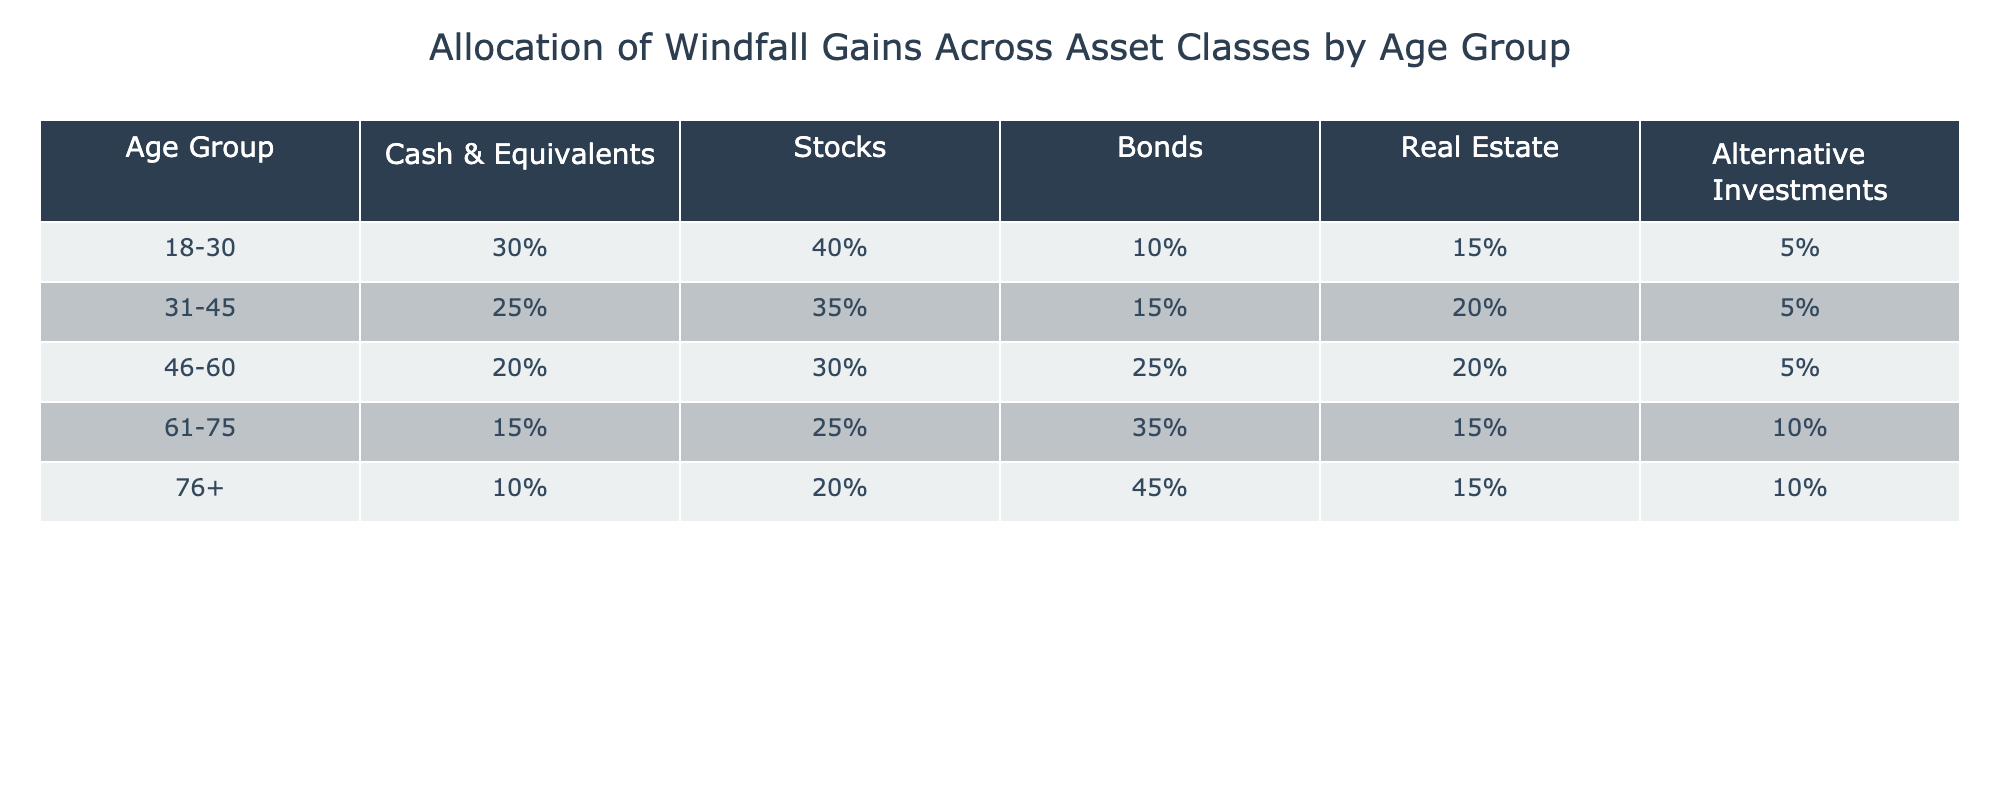What percentage of windfall gains for the 46-60 age group is allocated to stocks? The table shows a 30% allocation to stocks for the 46-60 age group.
Answer: 30% Which asset class gets the highest allocation for those aged 61-75? In the 61-75 age group, the highest allocation is 35% to bonds.
Answer: Bonds What is the difference in the allocation of cash and equivalents between the 18-30 and 76+ age groups? For the 18-30 age group the allocation is 30%, and for 76+ the allocation is 10%. The difference is 30% - 10% = 20%.
Answer: 20% Is the allocation to real estate higher for the 31-45 age group compared to the 76+ age group? The allocation for the 31-45 age group is 20%, and for the 76+ age group, it is 15%. Thus, it is higher for 31-45.
Answer: Yes What is the total percentage allocated to alternative investments across all age groups? Summing the alternative investments: 5% + 5% + 5% + 10% + 10% = 35%.
Answer: 35% Which age group has the lowest allocation to cash and equivalents, and what is that percentage? The 76+ age group has the lowest allocation at 10%.
Answer: 76+ age group, 10% What is the average allocation to bonds across all age groups? Adding the bond allocations: (10% + 15% + 25% + 35% + 45%) = 130%. Dividing by 5 (the number of age groups) gives 130% / 5 = 26%.
Answer: 26% Does the allocation to stocks increase or decrease as age increases? Comparing allocation: 40% (18-30), 35% (31-45), 30% (46-60), 25% (61-75), and 20% (76+) shows a decrease with age.
Answer: Decrease What percentage of total allocations for age group 46-60 is dedicated to cash and bonds combined? The allocation for cash is 20% and for bonds is 25%. Combined they equal 20% + 25% = 45%.
Answer: 45% Which age group has a higher percentage allocation to alternative investments: 61-75 or 76+? The 61-75 age group has 10% in alternatives while the 76+ also has 10%; they are equal.
Answer: They are equal 